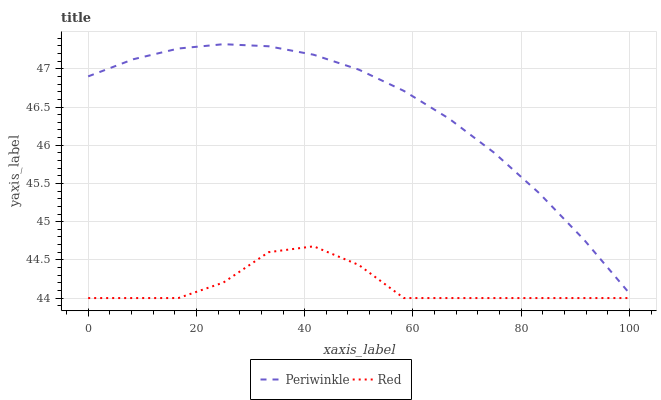Does Red have the minimum area under the curve?
Answer yes or no. Yes. Does Periwinkle have the maximum area under the curve?
Answer yes or no. Yes. Does Red have the maximum area under the curve?
Answer yes or no. No. Is Periwinkle the smoothest?
Answer yes or no. Yes. Is Red the roughest?
Answer yes or no. Yes. Is Red the smoothest?
Answer yes or no. No. Does Red have the lowest value?
Answer yes or no. Yes. Does Periwinkle have the highest value?
Answer yes or no. Yes. Does Red have the highest value?
Answer yes or no. No. Is Red less than Periwinkle?
Answer yes or no. Yes. Is Periwinkle greater than Red?
Answer yes or no. Yes. Does Red intersect Periwinkle?
Answer yes or no. No. 